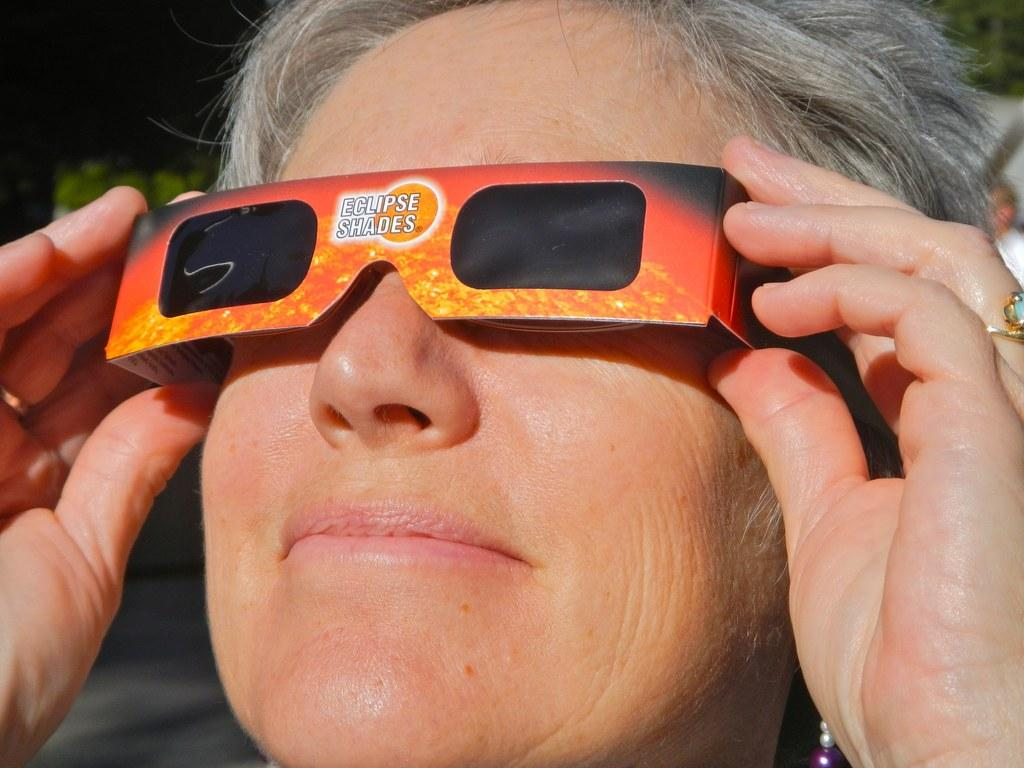What is present in the image? There is a person in the image. What is the person wearing on his eyes? The person is wearing shades on his eyes. What is the person doing in the image? The person is staring at something. How many ducks are visible in the image? There are no ducks present in the image. What is the person doing to increase the speed of the carriage in the image? There is no carriage present in the image, and the person is not performing any actions related to increasing speed. 